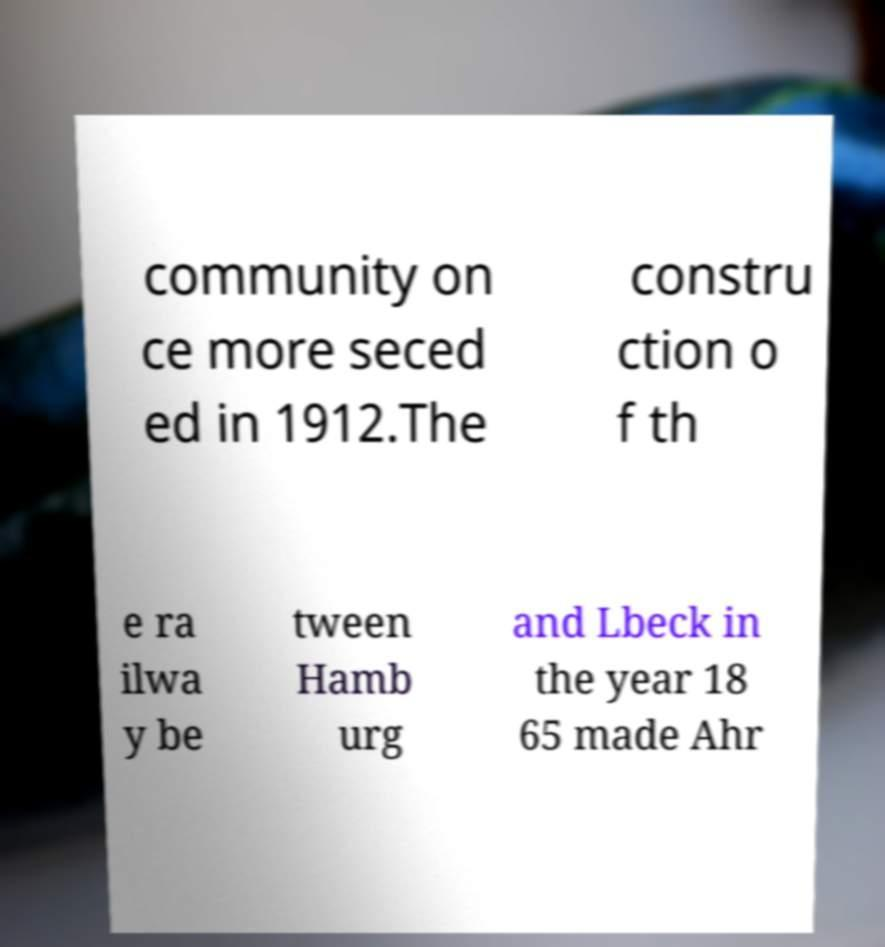Could you extract and type out the text from this image? community on ce more seced ed in 1912.The constru ction o f th e ra ilwa y be tween Hamb urg and Lbeck in the year 18 65 made Ahr 